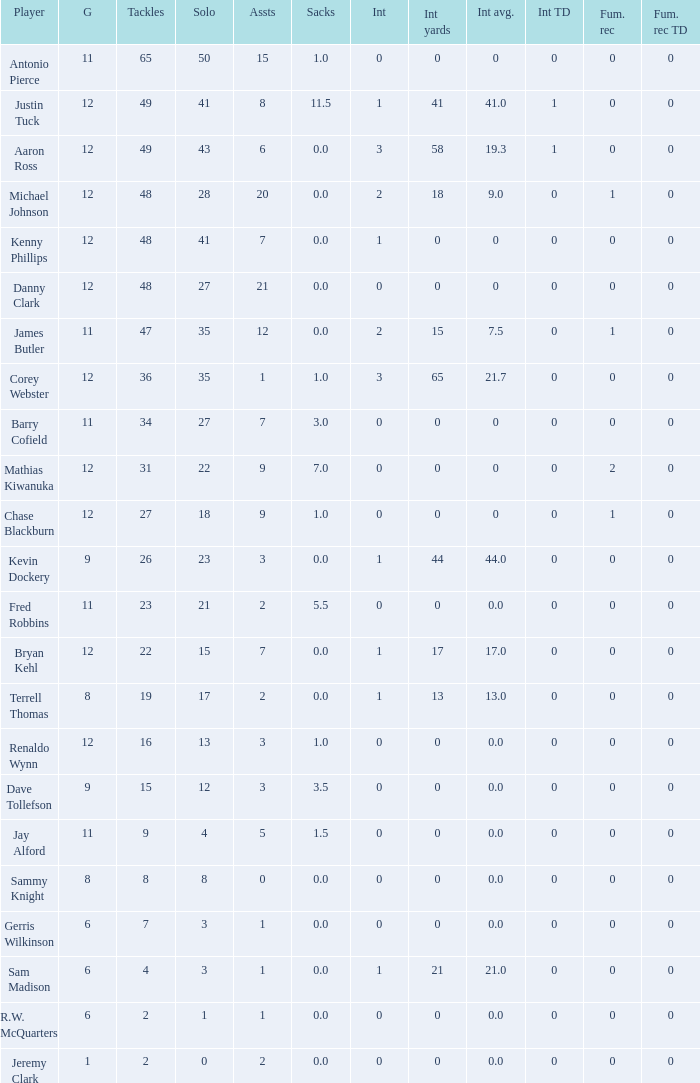Name the least amount of int yards 0.0. 